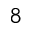<formula> <loc_0><loc_0><loc_500><loc_500>^ { 8 }</formula> 